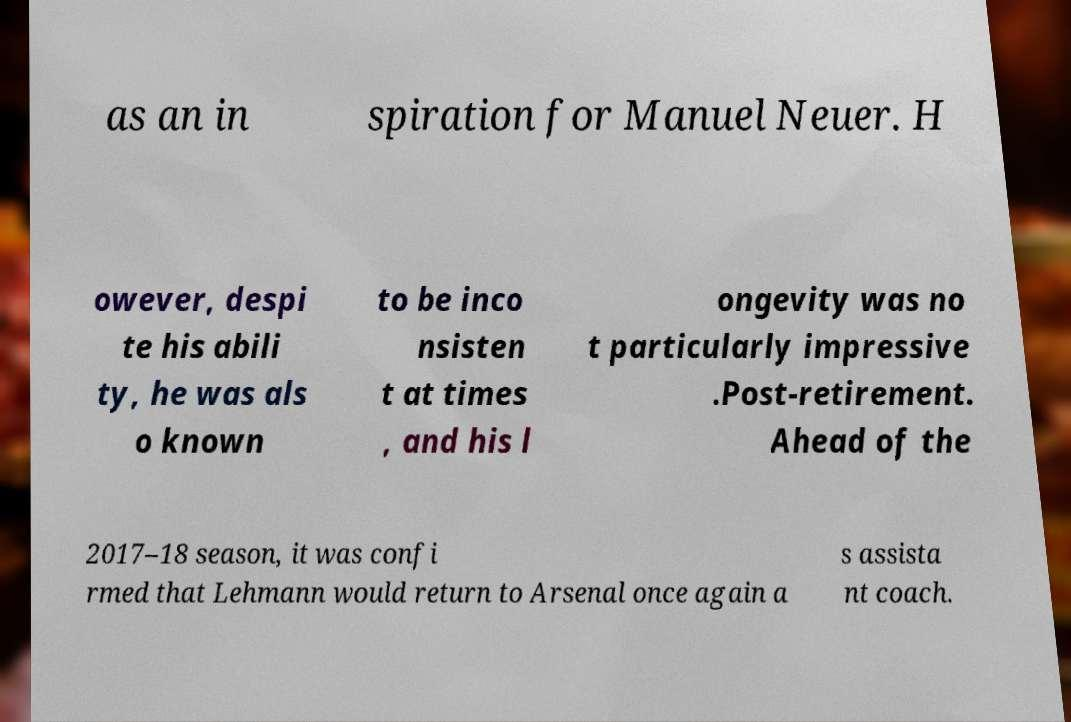What messages or text are displayed in this image? I need them in a readable, typed format. as an in spiration for Manuel Neuer. H owever, despi te his abili ty, he was als o known to be inco nsisten t at times , and his l ongevity was no t particularly impressive .Post-retirement. Ahead of the 2017–18 season, it was confi rmed that Lehmann would return to Arsenal once again a s assista nt coach. 